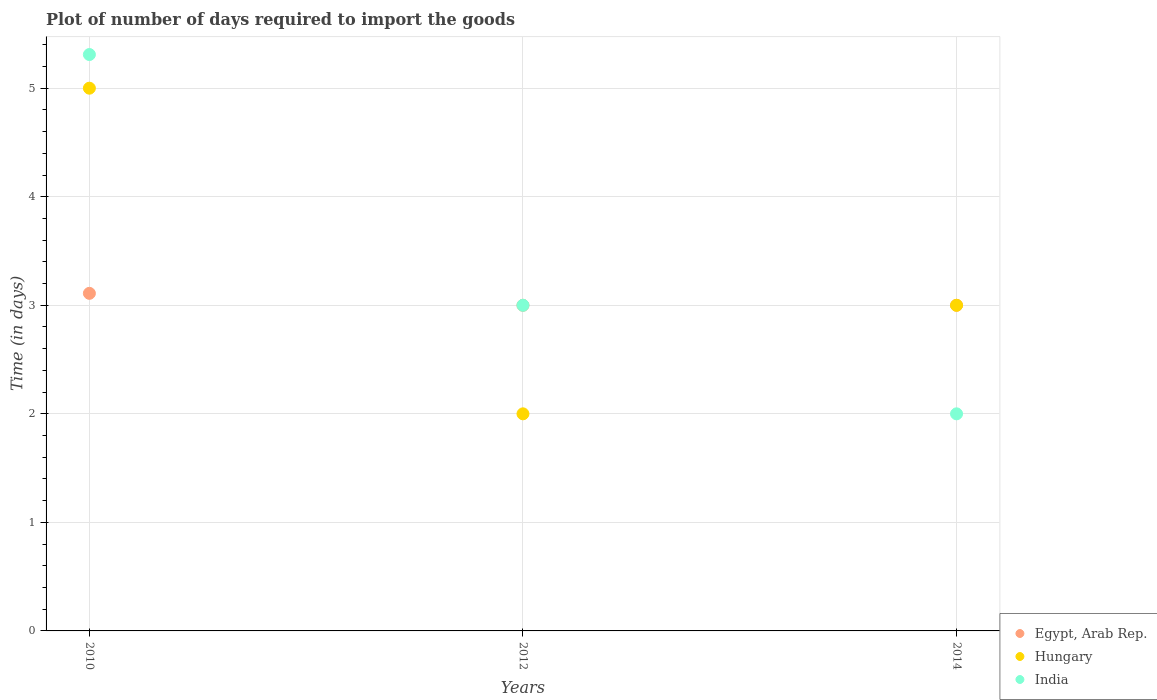Is the number of dotlines equal to the number of legend labels?
Provide a short and direct response. Yes. What is the time required to import goods in Egypt, Arab Rep. in 2012?
Offer a very short reply. 3. Across all years, what is the maximum time required to import goods in India?
Offer a very short reply. 5.31. In which year was the time required to import goods in Egypt, Arab Rep. maximum?
Ensure brevity in your answer.  2010. In which year was the time required to import goods in India minimum?
Provide a short and direct response. 2014. What is the total time required to import goods in Hungary in the graph?
Keep it short and to the point. 10. What is the difference between the time required to import goods in India in 2010 and that in 2012?
Provide a succinct answer. 2.31. What is the difference between the time required to import goods in India in 2014 and the time required to import goods in Egypt, Arab Rep. in 2012?
Your response must be concise. -1. What is the average time required to import goods in Egypt, Arab Rep. per year?
Offer a terse response. 3.04. In how many years, is the time required to import goods in India greater than 1.2 days?
Give a very brief answer. 3. What is the ratio of the time required to import goods in India in 2010 to that in 2012?
Make the answer very short. 1.77. Is the time required to import goods in Egypt, Arab Rep. in 2010 less than that in 2014?
Provide a succinct answer. No. Is the difference between the time required to import goods in Egypt, Arab Rep. in 2010 and 2014 greater than the difference between the time required to import goods in Hungary in 2010 and 2014?
Give a very brief answer. No. What is the difference between the highest and the second highest time required to import goods in Hungary?
Your answer should be very brief. 2. Is the sum of the time required to import goods in Hungary in 2012 and 2014 greater than the maximum time required to import goods in Egypt, Arab Rep. across all years?
Give a very brief answer. Yes. Is it the case that in every year, the sum of the time required to import goods in Hungary and time required to import goods in India  is greater than the time required to import goods in Egypt, Arab Rep.?
Offer a terse response. Yes. Does the time required to import goods in Hungary monotonically increase over the years?
Your answer should be compact. No. What is the difference between two consecutive major ticks on the Y-axis?
Offer a terse response. 1. Does the graph contain any zero values?
Your answer should be compact. No. How many legend labels are there?
Keep it short and to the point. 3. What is the title of the graph?
Ensure brevity in your answer.  Plot of number of days required to import the goods. What is the label or title of the X-axis?
Ensure brevity in your answer.  Years. What is the label or title of the Y-axis?
Keep it short and to the point. Time (in days). What is the Time (in days) in Egypt, Arab Rep. in 2010?
Keep it short and to the point. 3.11. What is the Time (in days) in India in 2010?
Keep it short and to the point. 5.31. What is the Time (in days) of Egypt, Arab Rep. in 2012?
Your response must be concise. 3. What is the Time (in days) of Egypt, Arab Rep. in 2014?
Your answer should be compact. 3. Across all years, what is the maximum Time (in days) in Egypt, Arab Rep.?
Offer a very short reply. 3.11. Across all years, what is the maximum Time (in days) in India?
Provide a succinct answer. 5.31. Across all years, what is the minimum Time (in days) of Hungary?
Provide a succinct answer. 2. What is the total Time (in days) in Egypt, Arab Rep. in the graph?
Make the answer very short. 9.11. What is the total Time (in days) in India in the graph?
Make the answer very short. 10.31. What is the difference between the Time (in days) in Egypt, Arab Rep. in 2010 and that in 2012?
Ensure brevity in your answer.  0.11. What is the difference between the Time (in days) in India in 2010 and that in 2012?
Offer a very short reply. 2.31. What is the difference between the Time (in days) of Egypt, Arab Rep. in 2010 and that in 2014?
Provide a succinct answer. 0.11. What is the difference between the Time (in days) in India in 2010 and that in 2014?
Provide a short and direct response. 3.31. What is the difference between the Time (in days) of Egypt, Arab Rep. in 2010 and the Time (in days) of Hungary in 2012?
Offer a terse response. 1.11. What is the difference between the Time (in days) of Egypt, Arab Rep. in 2010 and the Time (in days) of India in 2012?
Keep it short and to the point. 0.11. What is the difference between the Time (in days) of Hungary in 2010 and the Time (in days) of India in 2012?
Provide a short and direct response. 2. What is the difference between the Time (in days) of Egypt, Arab Rep. in 2010 and the Time (in days) of Hungary in 2014?
Your response must be concise. 0.11. What is the difference between the Time (in days) in Egypt, Arab Rep. in 2010 and the Time (in days) in India in 2014?
Offer a terse response. 1.11. What is the difference between the Time (in days) in Hungary in 2010 and the Time (in days) in India in 2014?
Ensure brevity in your answer.  3. What is the difference between the Time (in days) in Egypt, Arab Rep. in 2012 and the Time (in days) in India in 2014?
Keep it short and to the point. 1. What is the difference between the Time (in days) in Hungary in 2012 and the Time (in days) in India in 2014?
Make the answer very short. 0. What is the average Time (in days) of Egypt, Arab Rep. per year?
Provide a succinct answer. 3.04. What is the average Time (in days) in Hungary per year?
Ensure brevity in your answer.  3.33. What is the average Time (in days) of India per year?
Offer a terse response. 3.44. In the year 2010, what is the difference between the Time (in days) of Egypt, Arab Rep. and Time (in days) of Hungary?
Ensure brevity in your answer.  -1.89. In the year 2010, what is the difference between the Time (in days) in Egypt, Arab Rep. and Time (in days) in India?
Give a very brief answer. -2.2. In the year 2010, what is the difference between the Time (in days) of Hungary and Time (in days) of India?
Ensure brevity in your answer.  -0.31. In the year 2014, what is the difference between the Time (in days) of Egypt, Arab Rep. and Time (in days) of Hungary?
Ensure brevity in your answer.  0. What is the ratio of the Time (in days) in Egypt, Arab Rep. in 2010 to that in 2012?
Provide a succinct answer. 1.04. What is the ratio of the Time (in days) of Hungary in 2010 to that in 2012?
Your answer should be compact. 2.5. What is the ratio of the Time (in days) of India in 2010 to that in 2012?
Offer a terse response. 1.77. What is the ratio of the Time (in days) of Egypt, Arab Rep. in 2010 to that in 2014?
Your answer should be compact. 1.04. What is the ratio of the Time (in days) in India in 2010 to that in 2014?
Your response must be concise. 2.65. What is the ratio of the Time (in days) in India in 2012 to that in 2014?
Keep it short and to the point. 1.5. What is the difference between the highest and the second highest Time (in days) in Egypt, Arab Rep.?
Your response must be concise. 0.11. What is the difference between the highest and the second highest Time (in days) of Hungary?
Offer a terse response. 2. What is the difference between the highest and the second highest Time (in days) in India?
Make the answer very short. 2.31. What is the difference between the highest and the lowest Time (in days) in Egypt, Arab Rep.?
Your response must be concise. 0.11. What is the difference between the highest and the lowest Time (in days) in Hungary?
Make the answer very short. 3. What is the difference between the highest and the lowest Time (in days) in India?
Your answer should be very brief. 3.31. 